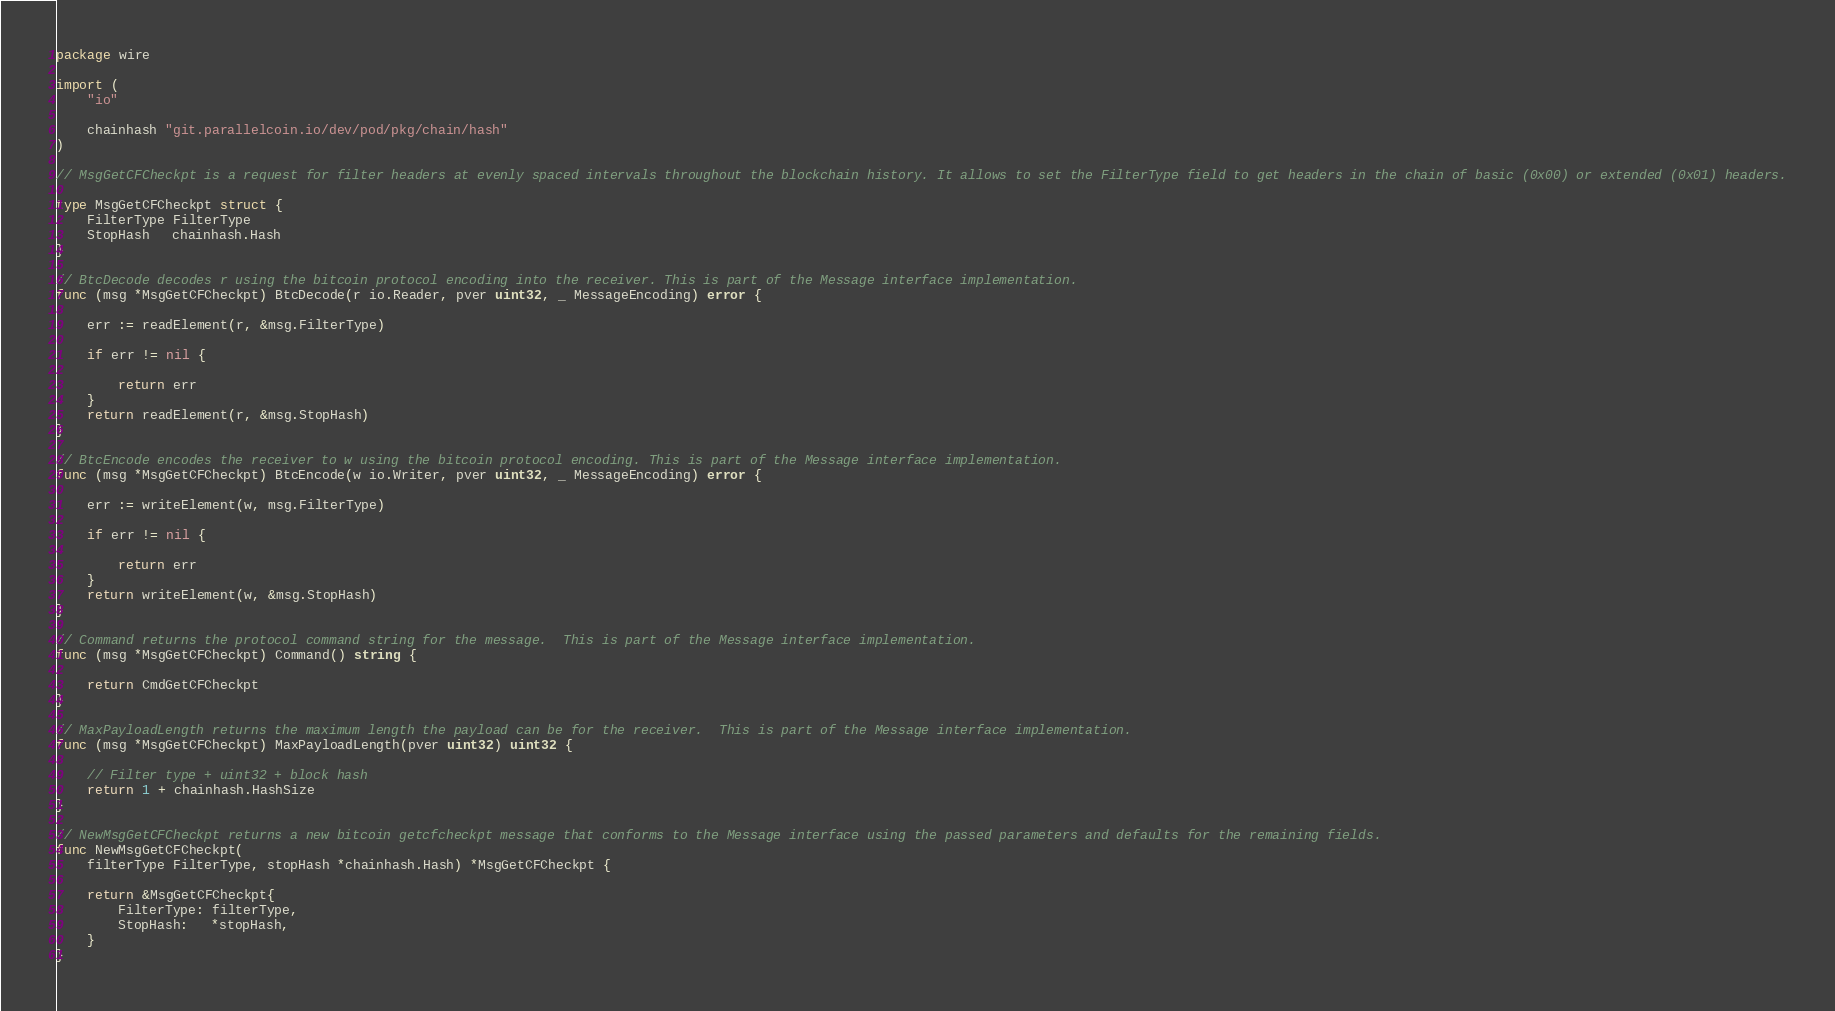<code> <loc_0><loc_0><loc_500><loc_500><_Go_>package wire

import (
	"io"

	chainhash "git.parallelcoin.io/dev/pod/pkg/chain/hash"
)

// MsgGetCFCheckpt is a request for filter headers at evenly spaced intervals throughout the blockchain history. It allows to set the FilterType field to get headers in the chain of basic (0x00) or extended (0x01) headers.

type MsgGetCFCheckpt struct {
	FilterType FilterType
	StopHash   chainhash.Hash
}

// BtcDecode decodes r using the bitcoin protocol encoding into the receiver. This is part of the Message interface implementation.
func (msg *MsgGetCFCheckpt) BtcDecode(r io.Reader, pver uint32, _ MessageEncoding) error {

	err := readElement(r, &msg.FilterType)

	if err != nil {

		return err
	}
	return readElement(r, &msg.StopHash)
}

// BtcEncode encodes the receiver to w using the bitcoin protocol encoding. This is part of the Message interface implementation.
func (msg *MsgGetCFCheckpt) BtcEncode(w io.Writer, pver uint32, _ MessageEncoding) error {

	err := writeElement(w, msg.FilterType)

	if err != nil {

		return err
	}
	return writeElement(w, &msg.StopHash)
}

// Command returns the protocol command string for the message.  This is part of the Message interface implementation.
func (msg *MsgGetCFCheckpt) Command() string {

	return CmdGetCFCheckpt
}

// MaxPayloadLength returns the maximum length the payload can be for the receiver.  This is part of the Message interface implementation.
func (msg *MsgGetCFCheckpt) MaxPayloadLength(pver uint32) uint32 {

	// Filter type + uint32 + block hash
	return 1 + chainhash.HashSize
}

// NewMsgGetCFCheckpt returns a new bitcoin getcfcheckpt message that conforms to the Message interface using the passed parameters and defaults for the remaining fields.
func NewMsgGetCFCheckpt(
	filterType FilterType, stopHash *chainhash.Hash) *MsgGetCFCheckpt {

	return &MsgGetCFCheckpt{
		FilterType: filterType,
		StopHash:   *stopHash,
	}
}
</code> 